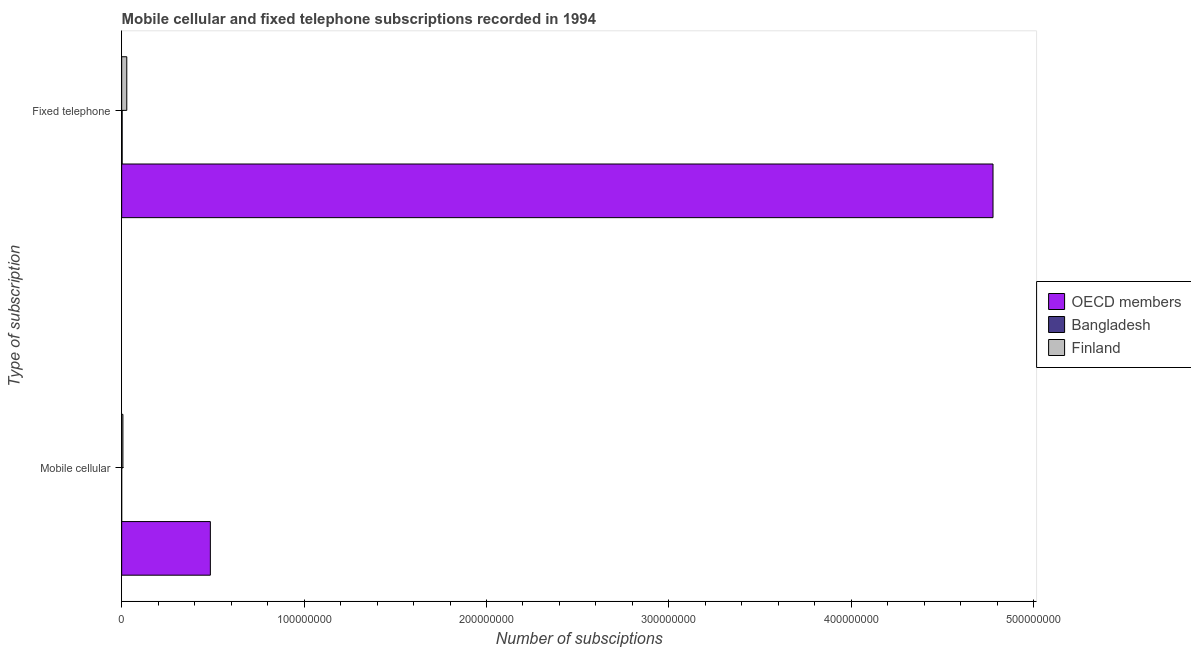How many groups of bars are there?
Give a very brief answer. 2. Are the number of bars on each tick of the Y-axis equal?
Offer a terse response. Yes. How many bars are there on the 2nd tick from the top?
Keep it short and to the point. 3. What is the label of the 2nd group of bars from the top?
Ensure brevity in your answer.  Mobile cellular. What is the number of fixed telephone subscriptions in OECD members?
Your answer should be compact. 4.78e+08. Across all countries, what is the maximum number of fixed telephone subscriptions?
Your answer should be very brief. 4.78e+08. Across all countries, what is the minimum number of fixed telephone subscriptions?
Ensure brevity in your answer.  2.62e+05. What is the total number of fixed telephone subscriptions in the graph?
Provide a succinct answer. 4.81e+08. What is the difference between the number of mobile cellular subscriptions in Finland and that in OECD members?
Your answer should be compact. -4.79e+07. What is the difference between the number of fixed telephone subscriptions in Finland and the number of mobile cellular subscriptions in Bangladesh?
Your response must be concise. 2.80e+06. What is the average number of fixed telephone subscriptions per country?
Offer a terse response. 1.60e+08. What is the difference between the number of mobile cellular subscriptions and number of fixed telephone subscriptions in Bangladesh?
Offer a very short reply. -2.61e+05. What is the ratio of the number of fixed telephone subscriptions in OECD members to that in Finland?
Offer a terse response. 170.54. In how many countries, is the number of fixed telephone subscriptions greater than the average number of fixed telephone subscriptions taken over all countries?
Ensure brevity in your answer.  1. What does the 3rd bar from the top in Mobile cellular represents?
Your response must be concise. OECD members. How many bars are there?
Keep it short and to the point. 6. Are all the bars in the graph horizontal?
Your response must be concise. Yes. Does the graph contain any zero values?
Your response must be concise. No. Does the graph contain grids?
Keep it short and to the point. No. Where does the legend appear in the graph?
Your answer should be compact. Center right. How many legend labels are there?
Offer a terse response. 3. What is the title of the graph?
Keep it short and to the point. Mobile cellular and fixed telephone subscriptions recorded in 1994. Does "Ethiopia" appear as one of the legend labels in the graph?
Provide a succinct answer. No. What is the label or title of the X-axis?
Offer a very short reply. Number of subsciptions. What is the label or title of the Y-axis?
Your answer should be compact. Type of subscription. What is the Number of subsciptions of OECD members in Mobile cellular?
Make the answer very short. 4.86e+07. What is the Number of subsciptions of Bangladesh in Mobile cellular?
Offer a terse response. 1104. What is the Number of subsciptions of Finland in Mobile cellular?
Ensure brevity in your answer.  6.76e+05. What is the Number of subsciptions in OECD members in Fixed telephone?
Your response must be concise. 4.78e+08. What is the Number of subsciptions in Bangladesh in Fixed telephone?
Keep it short and to the point. 2.62e+05. What is the Number of subsciptions in Finland in Fixed telephone?
Offer a terse response. 2.80e+06. Across all Type of subscription, what is the maximum Number of subsciptions in OECD members?
Offer a very short reply. 4.78e+08. Across all Type of subscription, what is the maximum Number of subsciptions of Bangladesh?
Ensure brevity in your answer.  2.62e+05. Across all Type of subscription, what is the maximum Number of subsciptions of Finland?
Ensure brevity in your answer.  2.80e+06. Across all Type of subscription, what is the minimum Number of subsciptions of OECD members?
Ensure brevity in your answer.  4.86e+07. Across all Type of subscription, what is the minimum Number of subsciptions of Bangladesh?
Your answer should be very brief. 1104. Across all Type of subscription, what is the minimum Number of subsciptions of Finland?
Offer a terse response. 6.76e+05. What is the total Number of subsciptions in OECD members in the graph?
Provide a short and direct response. 5.26e+08. What is the total Number of subsciptions in Bangladesh in the graph?
Your answer should be compact. 2.63e+05. What is the total Number of subsciptions of Finland in the graph?
Offer a very short reply. 3.48e+06. What is the difference between the Number of subsciptions in OECD members in Mobile cellular and that in Fixed telephone?
Provide a short and direct response. -4.29e+08. What is the difference between the Number of subsciptions in Bangladesh in Mobile cellular and that in Fixed telephone?
Provide a short and direct response. -2.61e+05. What is the difference between the Number of subsciptions of Finland in Mobile cellular and that in Fixed telephone?
Offer a very short reply. -2.13e+06. What is the difference between the Number of subsciptions in OECD members in Mobile cellular and the Number of subsciptions in Bangladesh in Fixed telephone?
Provide a short and direct response. 4.84e+07. What is the difference between the Number of subsciptions in OECD members in Mobile cellular and the Number of subsciptions in Finland in Fixed telephone?
Your answer should be compact. 4.58e+07. What is the difference between the Number of subsciptions in Bangladesh in Mobile cellular and the Number of subsciptions in Finland in Fixed telephone?
Offer a very short reply. -2.80e+06. What is the average Number of subsciptions of OECD members per Type of subscription?
Offer a terse response. 2.63e+08. What is the average Number of subsciptions in Bangladesh per Type of subscription?
Make the answer very short. 1.32e+05. What is the average Number of subsciptions in Finland per Type of subscription?
Make the answer very short. 1.74e+06. What is the difference between the Number of subsciptions in OECD members and Number of subsciptions in Bangladesh in Mobile cellular?
Your answer should be very brief. 4.86e+07. What is the difference between the Number of subsciptions in OECD members and Number of subsciptions in Finland in Mobile cellular?
Offer a very short reply. 4.79e+07. What is the difference between the Number of subsciptions in Bangladesh and Number of subsciptions in Finland in Mobile cellular?
Your answer should be very brief. -6.74e+05. What is the difference between the Number of subsciptions of OECD members and Number of subsciptions of Bangladesh in Fixed telephone?
Offer a very short reply. 4.77e+08. What is the difference between the Number of subsciptions in OECD members and Number of subsciptions in Finland in Fixed telephone?
Offer a very short reply. 4.75e+08. What is the difference between the Number of subsciptions in Bangladesh and Number of subsciptions in Finland in Fixed telephone?
Your response must be concise. -2.54e+06. What is the ratio of the Number of subsciptions of OECD members in Mobile cellular to that in Fixed telephone?
Give a very brief answer. 0.1. What is the ratio of the Number of subsciptions of Bangladesh in Mobile cellular to that in Fixed telephone?
Your response must be concise. 0. What is the ratio of the Number of subsciptions of Finland in Mobile cellular to that in Fixed telephone?
Your answer should be very brief. 0.24. What is the difference between the highest and the second highest Number of subsciptions of OECD members?
Provide a succinct answer. 4.29e+08. What is the difference between the highest and the second highest Number of subsciptions of Bangladesh?
Give a very brief answer. 2.61e+05. What is the difference between the highest and the second highest Number of subsciptions of Finland?
Provide a succinct answer. 2.13e+06. What is the difference between the highest and the lowest Number of subsciptions in OECD members?
Your response must be concise. 4.29e+08. What is the difference between the highest and the lowest Number of subsciptions of Bangladesh?
Provide a succinct answer. 2.61e+05. What is the difference between the highest and the lowest Number of subsciptions of Finland?
Provide a short and direct response. 2.13e+06. 